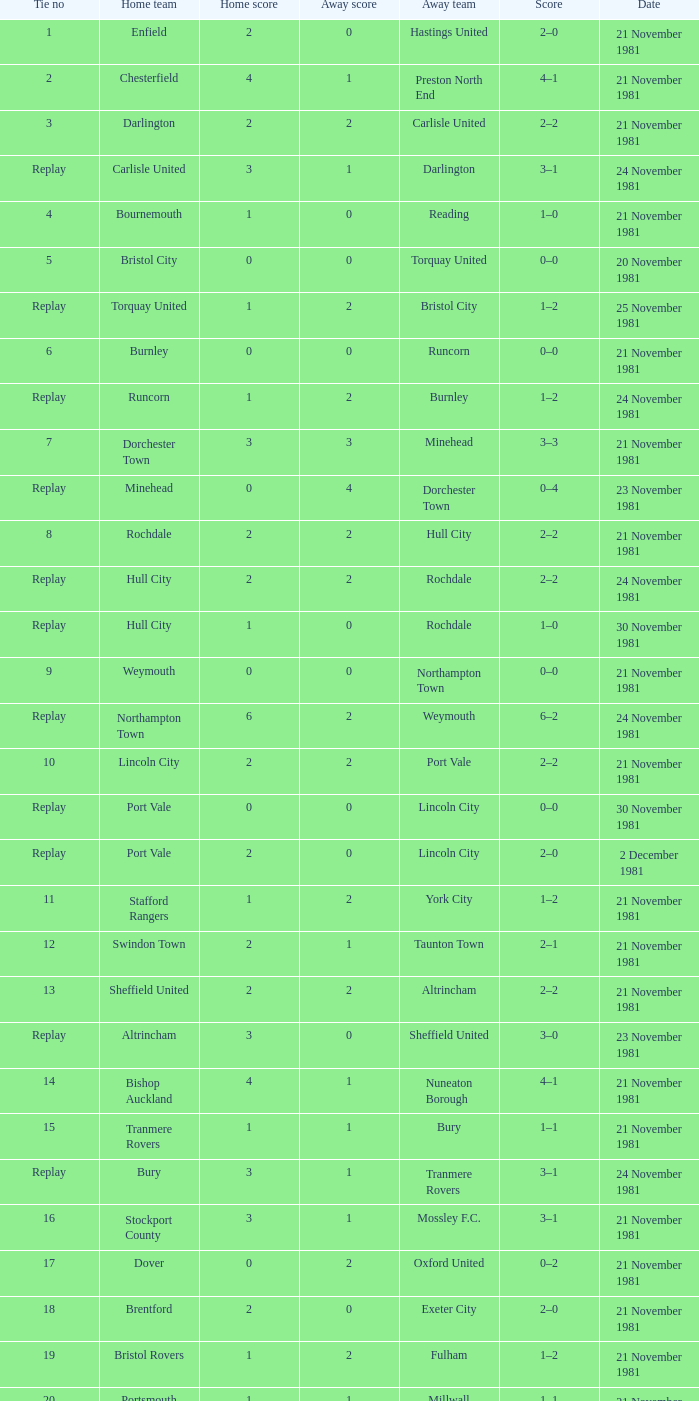What tie numeral does minehead have? Replay. 